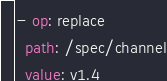Convert code to text. <code><loc_0><loc_0><loc_500><loc_500><_YAML_>- op: replace
  path: /spec/channel
  value: v1.4
</code> 